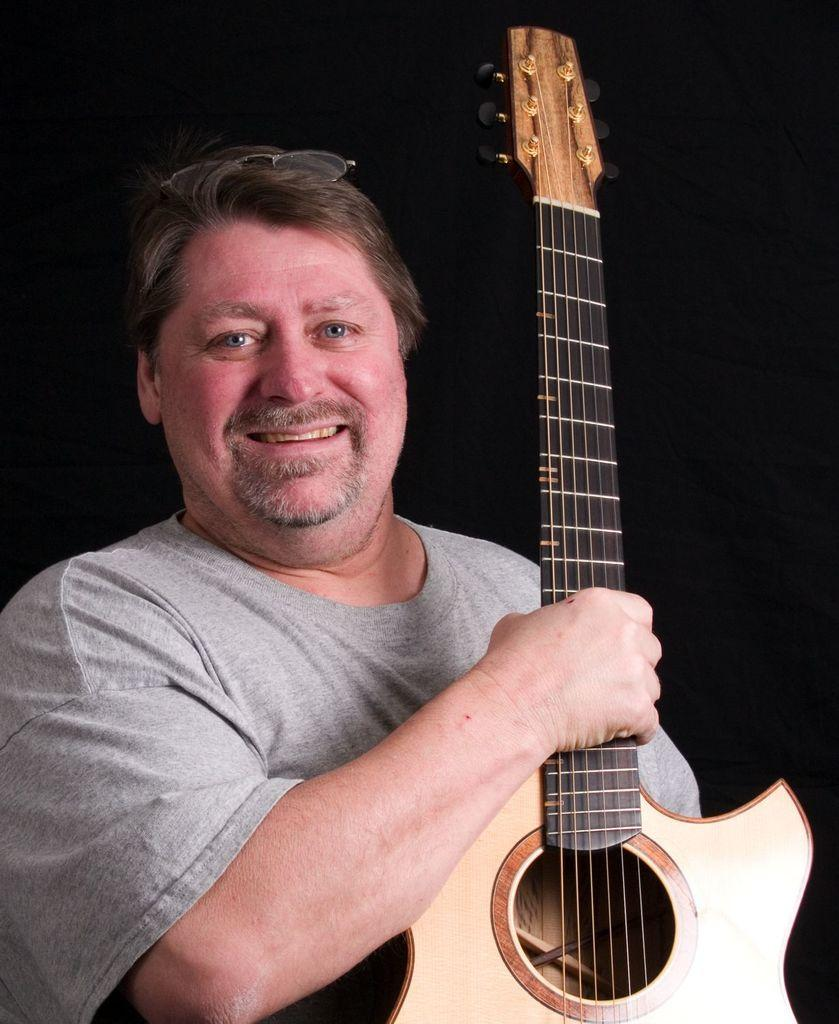What is the man in the image doing? The man is holding a guitar in the image. What is the man's facial expression in the image? The man is smiling in the image. What time is displayed on the clock in the image? There is no clock present in the image. 